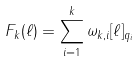<formula> <loc_0><loc_0><loc_500><loc_500>F _ { k } ( \ell ) = \sum _ { i = 1 } ^ { k } \omega _ { k , i } [ \ell ] _ { q _ { i } }</formula> 